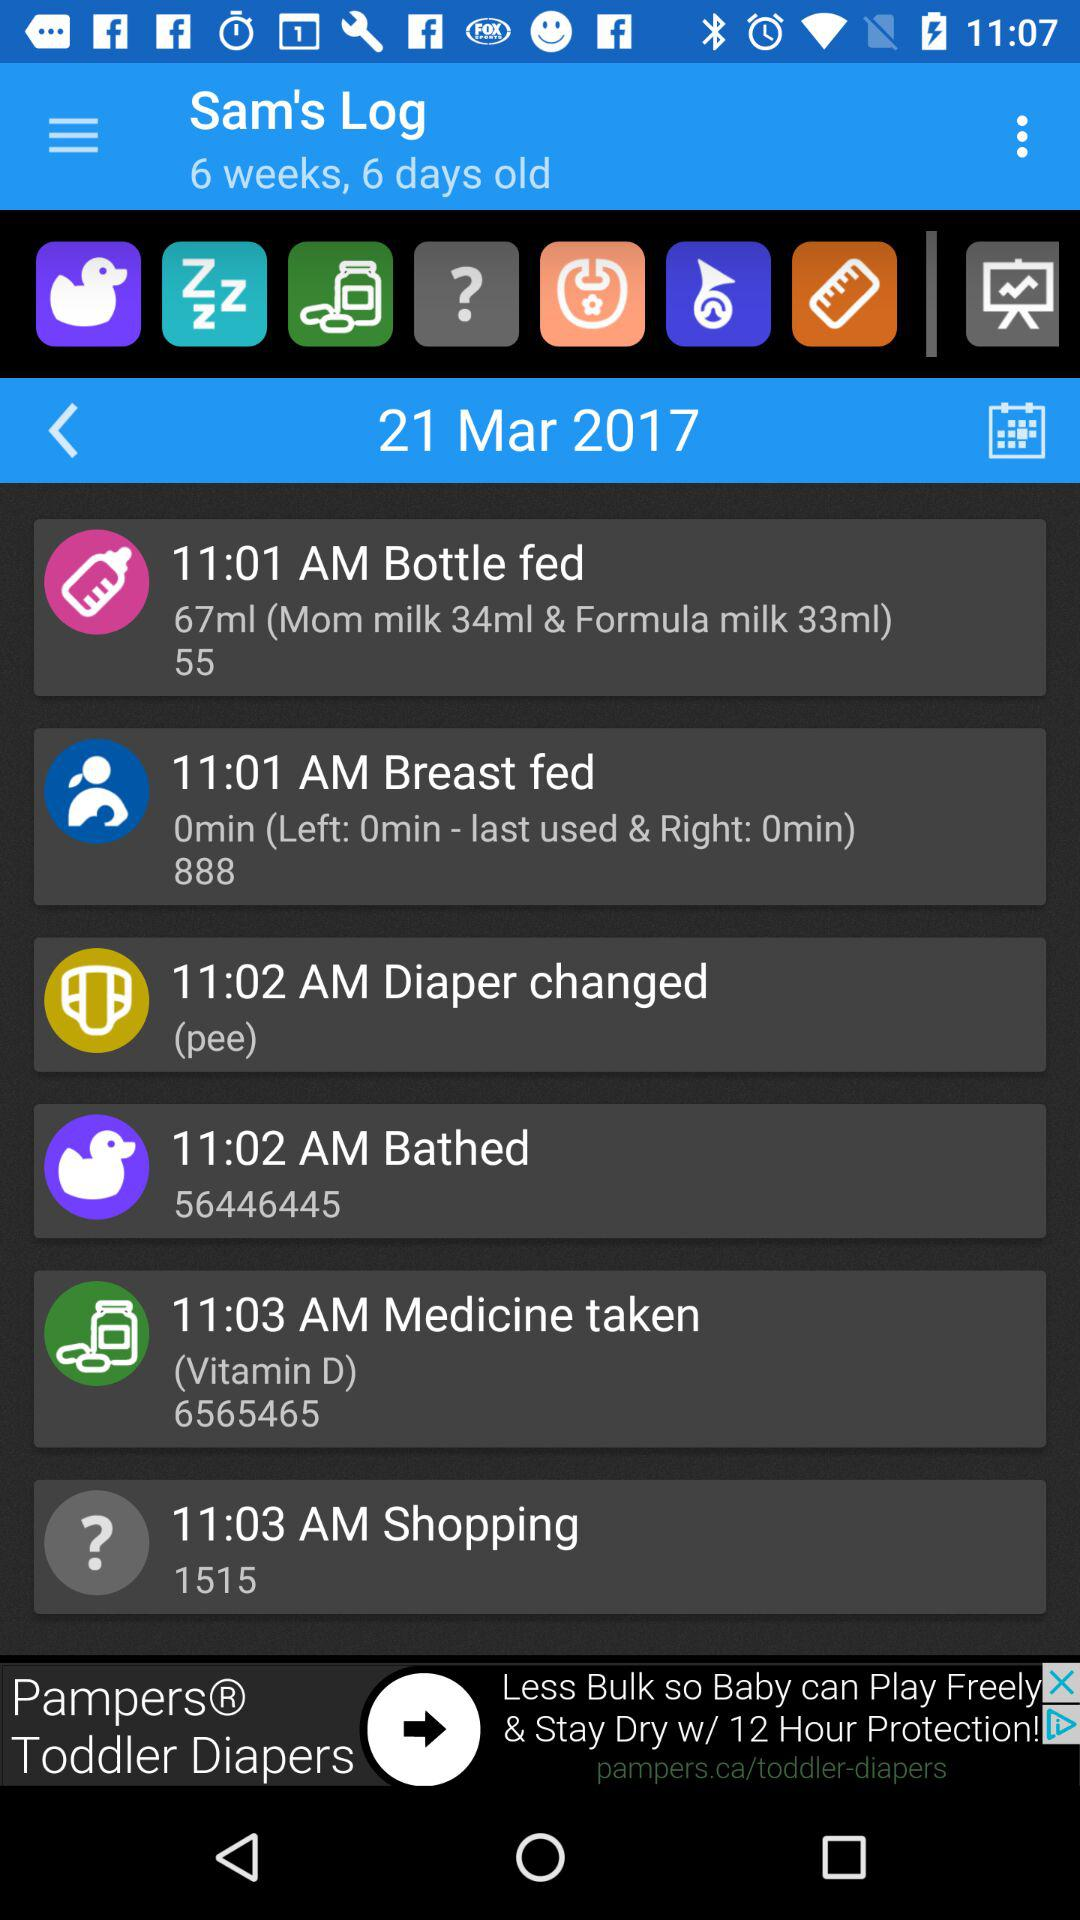How many days old is Sam's log? Sam's log is 6 weeks and 6 days old. 